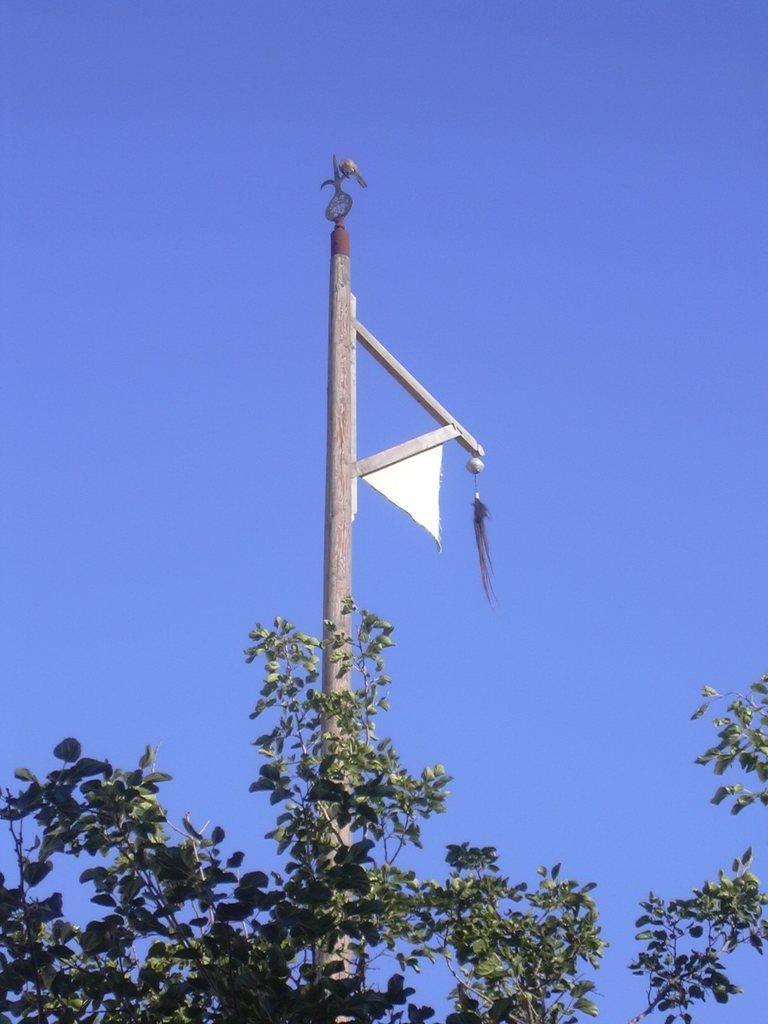What is the main object in the image? There is an iron pole in the image. What is attached to the iron pole? A cloth is hanged on the pole. What type of vegetation is present in the image? There is a tree in the image. What is the condition of the sky in the image? The sky is clear in the image. Can you see a patch on the tree in the image? There is no mention of a patch on the tree in the provided facts, so we cannot determine if one is present. Is there an uncle sitting on the swing in the image? There is no mention of a swing or an uncle in the provided facts, so we cannot determine if either is present. 